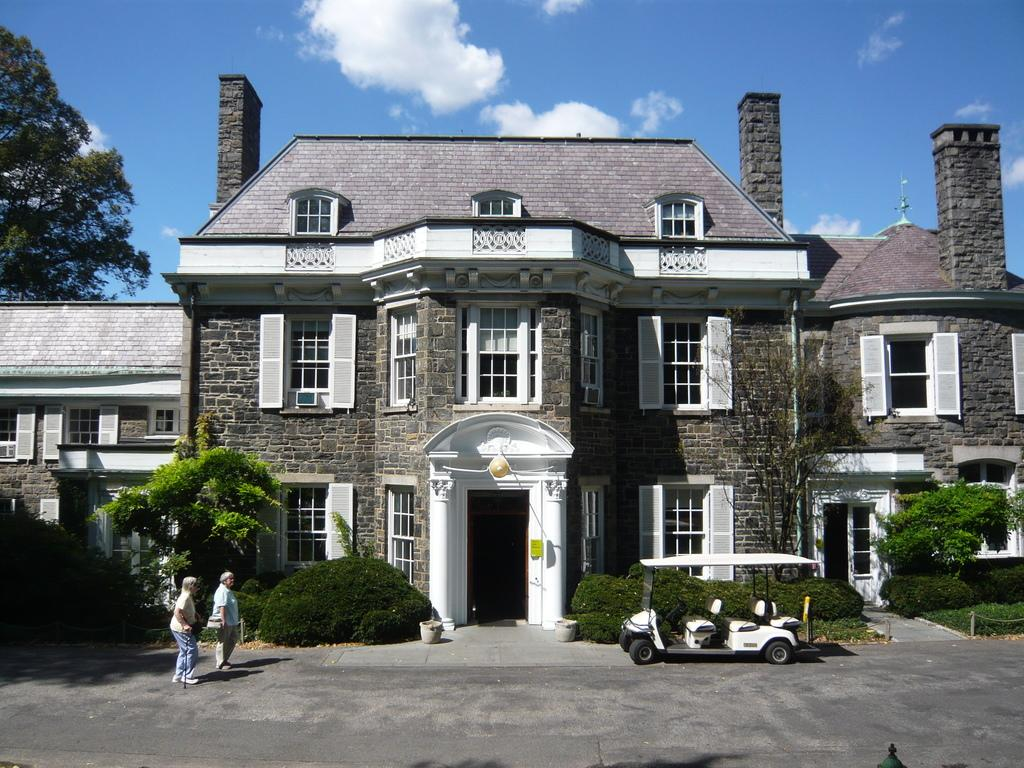What type of structure is present in the image? There is a building in the image. What can be seen in front of the building? There are shrubs in front of the building. Are there any people visible in the image? Yes, there are people in the image. What other objects can be seen in the image? There is a flower pot and a golf cart in the image. What type of vegetation is present in the image? There are trees in the image. What can be seen in the background of the image? There are clouds visible in the background. What is the price of the comfort offered by the trees in the image? There is no price associated with the comfort offered by the trees in the image, as they are not providing any comfort in a tangible sense. 